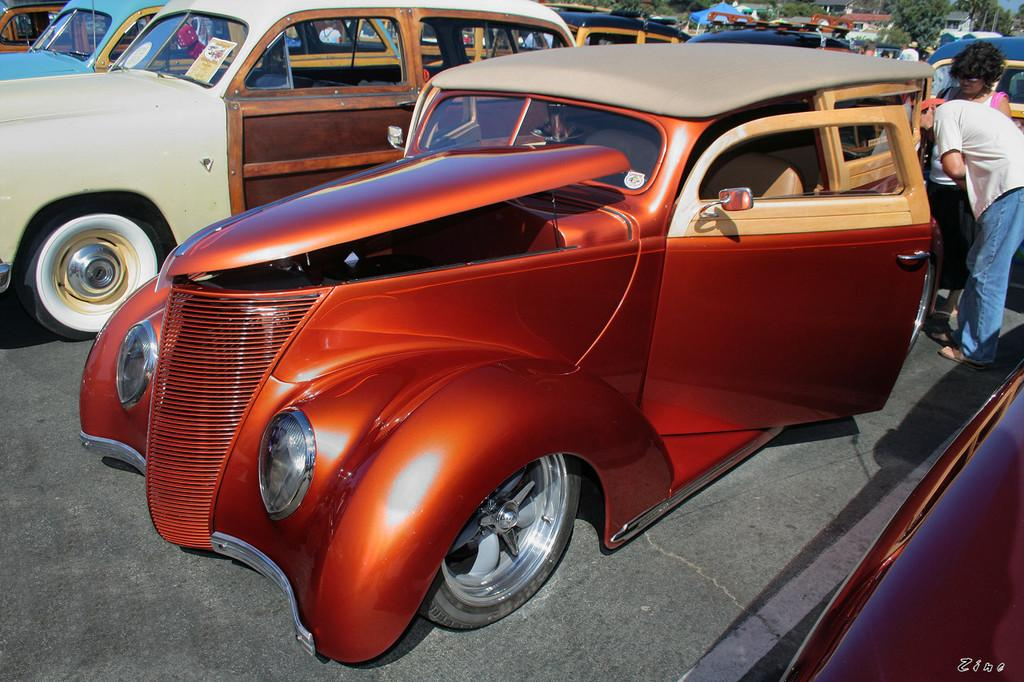Who or what can be seen in the image? There are people in the image. What else is visible in the image besides the people? There are vehicles on the road and tents in the background of the image. What type of natural elements can be seen in the background? There are trees in the background of the image. Are there any women skating on vacation in the image? There is no information about women skating on vacation in the image. 